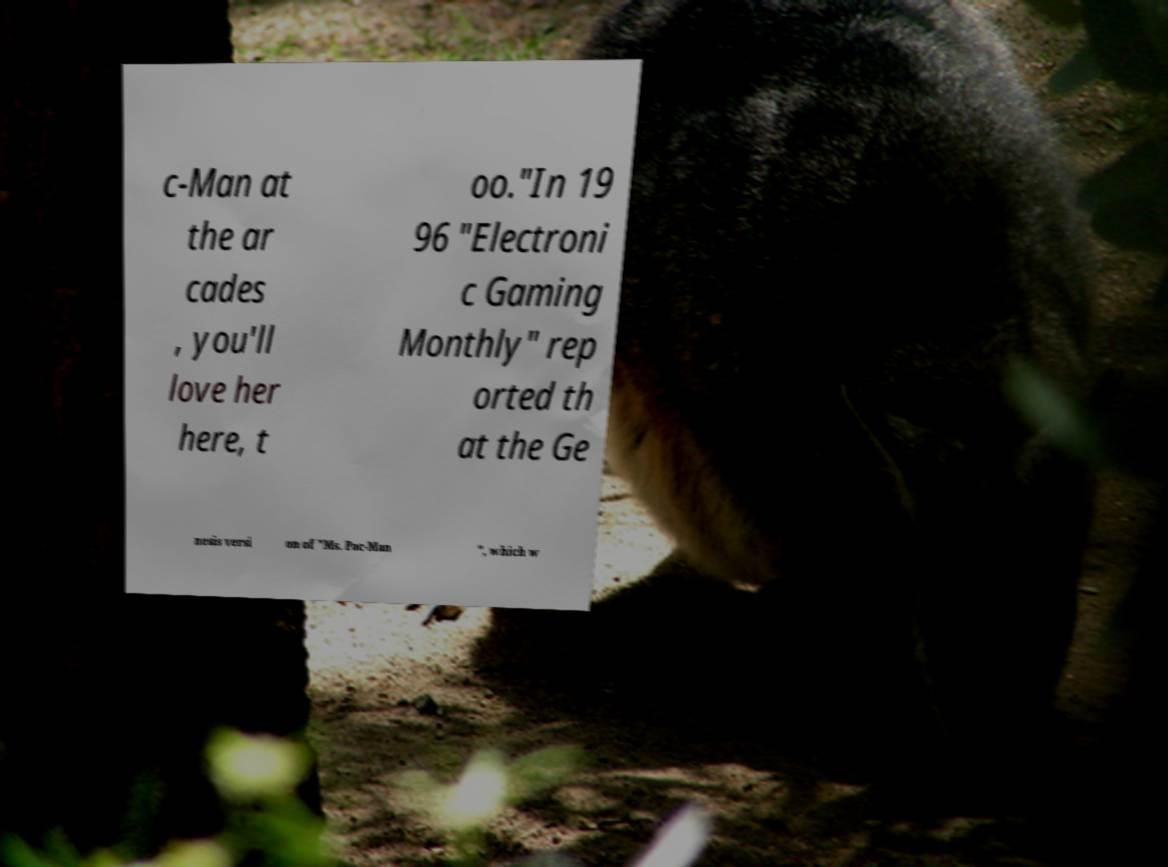What messages or text are displayed in this image? I need them in a readable, typed format. c-Man at the ar cades , you'll love her here, t oo."In 19 96 "Electroni c Gaming Monthly" rep orted th at the Ge nesis versi on of "Ms. Pac-Man ", which w 